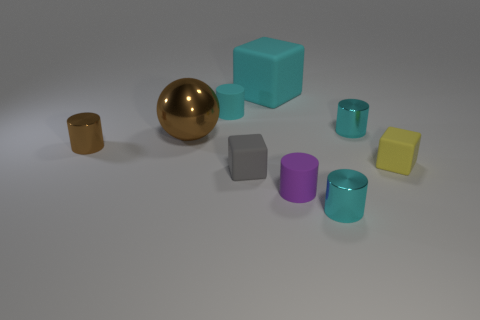There is a cyan object left of the large cyan matte block; does it have the same shape as the gray object?
Offer a very short reply. No. There is a tiny block left of the large cyan matte cube; what is its color?
Give a very brief answer. Gray. How many other objects are there of the same size as the purple rubber cylinder?
Keep it short and to the point. 6. Is there anything else that is the same shape as the small gray thing?
Your response must be concise. Yes. Are there an equal number of shiny spheres on the right side of the big matte cube and tiny rubber objects?
Provide a succinct answer. No. What number of tiny cyan objects are the same material as the big brown ball?
Your response must be concise. 2. The big cube that is the same material as the tiny gray block is what color?
Offer a terse response. Cyan. Does the purple rubber thing have the same shape as the tiny yellow rubber thing?
Your answer should be very brief. No. Is there a tiny cyan shiny thing that is left of the tiny cyan cylinder in front of the brown ball that is behind the purple rubber object?
Ensure brevity in your answer.  No. How many matte blocks have the same color as the large metallic sphere?
Your answer should be very brief. 0. 